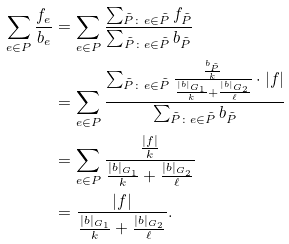Convert formula to latex. <formula><loc_0><loc_0><loc_500><loc_500>\sum _ { e \in P } \frac { f _ { e } } { b _ { e } } & = \sum _ { e \in P } \frac { \sum _ { \tilde { P } \colon e \in \tilde { P } } { f _ { \tilde { P } } } } { \sum _ { \tilde { P } \colon e \in \tilde { P } } { b _ { \tilde { P } } } } \\ & = \sum _ { e \in P } { \frac { \sum _ { \tilde { P } \colon e \in \tilde { P } } { \frac { \frac { b _ { \tilde { P } } } { k } } { \frac { | b | _ { G _ { 1 } } } { k } + \frac { | b | _ { G _ { 2 } } } { \ell } } \cdot | f | } } { \sum _ { \tilde { P } \colon e \in \tilde { P } } { b _ { \tilde { P } } } } } \\ & = \sum _ { e \in P } { \frac { \frac { | f | } { k } } { \frac { | b | _ { G _ { 1 } } } { k } + \frac { | b | _ { G _ { 2 } } } { \ell } } } \\ & = \frac { | f | } { \frac { | b | _ { G _ { 1 } } } { k } + \frac { | b | _ { G _ { 2 } } } { \ell } } .</formula> 